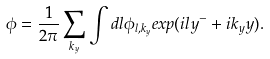<formula> <loc_0><loc_0><loc_500><loc_500>\phi = \frac { 1 } { 2 \pi } \sum _ { k _ { y } } \int d l \phi _ { l , k _ { y } } e x p ( i l y ^ { - } + i k _ { y } y ) .</formula> 